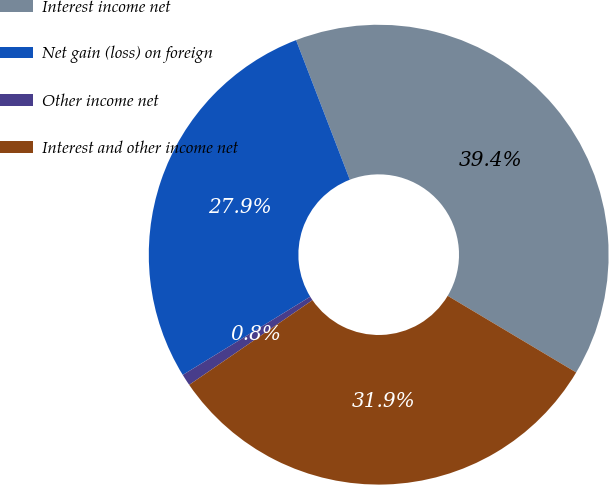Convert chart to OTSL. <chart><loc_0><loc_0><loc_500><loc_500><pie_chart><fcel>Interest income net<fcel>Net gain (loss) on foreign<fcel>Other income net<fcel>Interest and other income net<nl><fcel>39.41%<fcel>27.91%<fcel>0.82%<fcel>31.86%<nl></chart> 